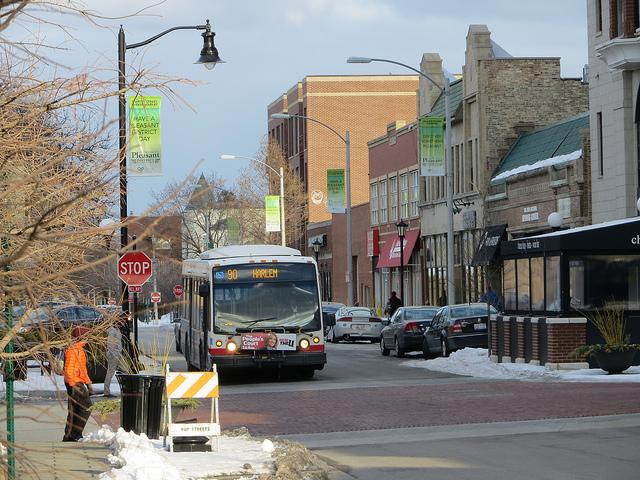Where is the bus headed to? harlem 